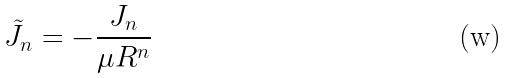Convert formula to latex. <formula><loc_0><loc_0><loc_500><loc_500>\tilde { J _ { n } } = - \frac { J _ { n } } { \mu R ^ { n } }</formula> 